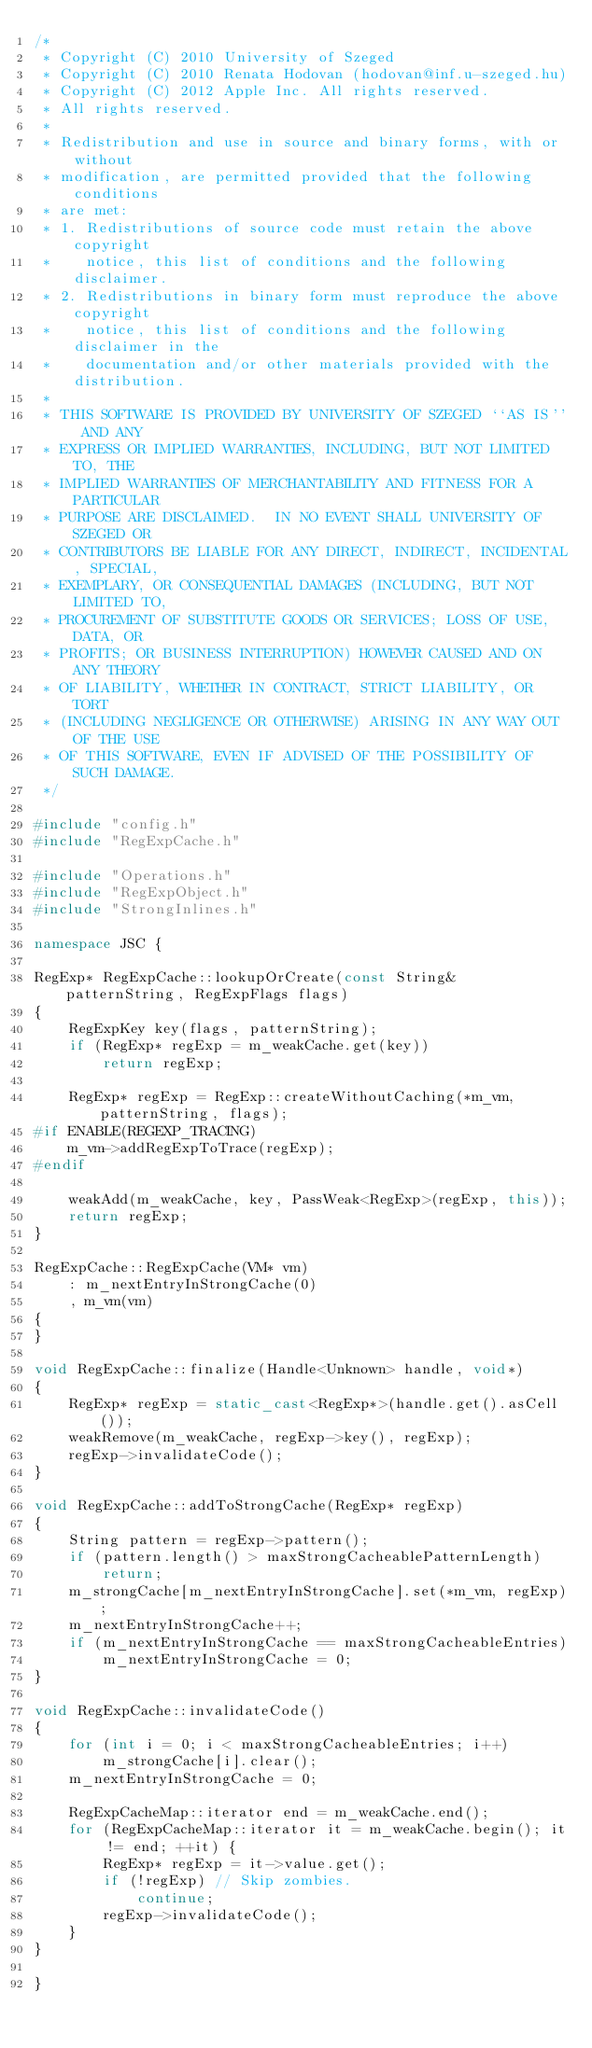Convert code to text. <code><loc_0><loc_0><loc_500><loc_500><_C++_>/*
 * Copyright (C) 2010 University of Szeged
 * Copyright (C) 2010 Renata Hodovan (hodovan@inf.u-szeged.hu)
 * Copyright (C) 2012 Apple Inc. All rights reserved.
 * All rights reserved.
 *
 * Redistribution and use in source and binary forms, with or without
 * modification, are permitted provided that the following conditions
 * are met:
 * 1. Redistributions of source code must retain the above copyright
 *    notice, this list of conditions and the following disclaimer.
 * 2. Redistributions in binary form must reproduce the above copyright
 *    notice, this list of conditions and the following disclaimer in the
 *    documentation and/or other materials provided with the distribution.
 *
 * THIS SOFTWARE IS PROVIDED BY UNIVERSITY OF SZEGED ``AS IS'' AND ANY
 * EXPRESS OR IMPLIED WARRANTIES, INCLUDING, BUT NOT LIMITED TO, THE
 * IMPLIED WARRANTIES OF MERCHANTABILITY AND FITNESS FOR A PARTICULAR
 * PURPOSE ARE DISCLAIMED.  IN NO EVENT SHALL UNIVERSITY OF SZEGED OR
 * CONTRIBUTORS BE LIABLE FOR ANY DIRECT, INDIRECT, INCIDENTAL, SPECIAL,
 * EXEMPLARY, OR CONSEQUENTIAL DAMAGES (INCLUDING, BUT NOT LIMITED TO,
 * PROCUREMENT OF SUBSTITUTE GOODS OR SERVICES; LOSS OF USE, DATA, OR
 * PROFITS; OR BUSINESS INTERRUPTION) HOWEVER CAUSED AND ON ANY THEORY
 * OF LIABILITY, WHETHER IN CONTRACT, STRICT LIABILITY, OR TORT
 * (INCLUDING NEGLIGENCE OR OTHERWISE) ARISING IN ANY WAY OUT OF THE USE
 * OF THIS SOFTWARE, EVEN IF ADVISED OF THE POSSIBILITY OF SUCH DAMAGE.
 */

#include "config.h"
#include "RegExpCache.h"

#include "Operations.h"
#include "RegExpObject.h"
#include "StrongInlines.h"

namespace JSC {

RegExp* RegExpCache::lookupOrCreate(const String& patternString, RegExpFlags flags)
{
    RegExpKey key(flags, patternString);
    if (RegExp* regExp = m_weakCache.get(key))
        return regExp;

    RegExp* regExp = RegExp::createWithoutCaching(*m_vm, patternString, flags);
#if ENABLE(REGEXP_TRACING)
    m_vm->addRegExpToTrace(regExp);
#endif

    weakAdd(m_weakCache, key, PassWeak<RegExp>(regExp, this));
    return regExp;
}

RegExpCache::RegExpCache(VM* vm)
    : m_nextEntryInStrongCache(0)
    , m_vm(vm)
{
}

void RegExpCache::finalize(Handle<Unknown> handle, void*)
{
    RegExp* regExp = static_cast<RegExp*>(handle.get().asCell());
    weakRemove(m_weakCache, regExp->key(), regExp);
    regExp->invalidateCode();
}

void RegExpCache::addToStrongCache(RegExp* regExp)
{
    String pattern = regExp->pattern();
    if (pattern.length() > maxStrongCacheablePatternLength)
        return;
    m_strongCache[m_nextEntryInStrongCache].set(*m_vm, regExp);
    m_nextEntryInStrongCache++;
    if (m_nextEntryInStrongCache == maxStrongCacheableEntries)
        m_nextEntryInStrongCache = 0;
}

void RegExpCache::invalidateCode()
{
    for (int i = 0; i < maxStrongCacheableEntries; i++)
        m_strongCache[i].clear();
    m_nextEntryInStrongCache = 0;

    RegExpCacheMap::iterator end = m_weakCache.end();
    for (RegExpCacheMap::iterator it = m_weakCache.begin(); it != end; ++it) {
        RegExp* regExp = it->value.get();
        if (!regExp) // Skip zombies.
            continue;
        regExp->invalidateCode();
    }
}

}
</code> 